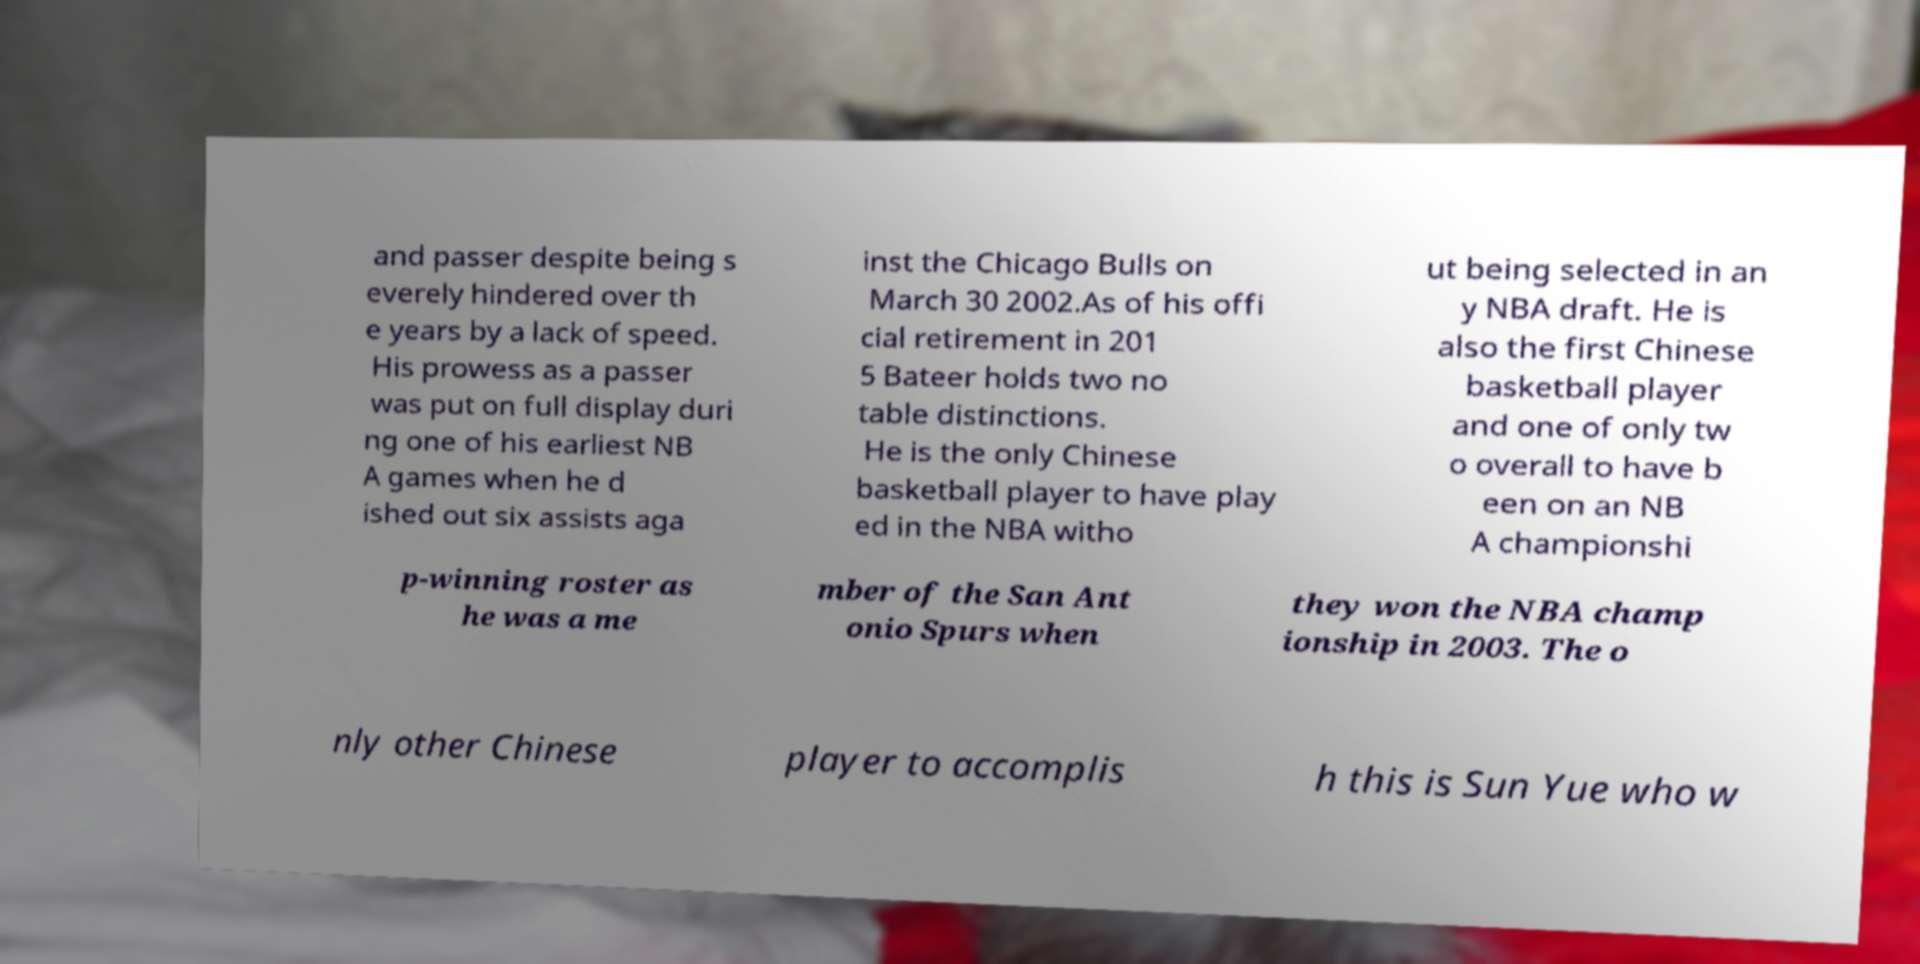Can you accurately transcribe the text from the provided image for me? and passer despite being s everely hindered over th e years by a lack of speed. His prowess as a passer was put on full display duri ng one of his earliest NB A games when he d ished out six assists aga inst the Chicago Bulls on March 30 2002.As of his offi cial retirement in 201 5 Bateer holds two no table distinctions. He is the only Chinese basketball player to have play ed in the NBA witho ut being selected in an y NBA draft. He is also the first Chinese basketball player and one of only tw o overall to have b een on an NB A championshi p-winning roster as he was a me mber of the San Ant onio Spurs when they won the NBA champ ionship in 2003. The o nly other Chinese player to accomplis h this is Sun Yue who w 